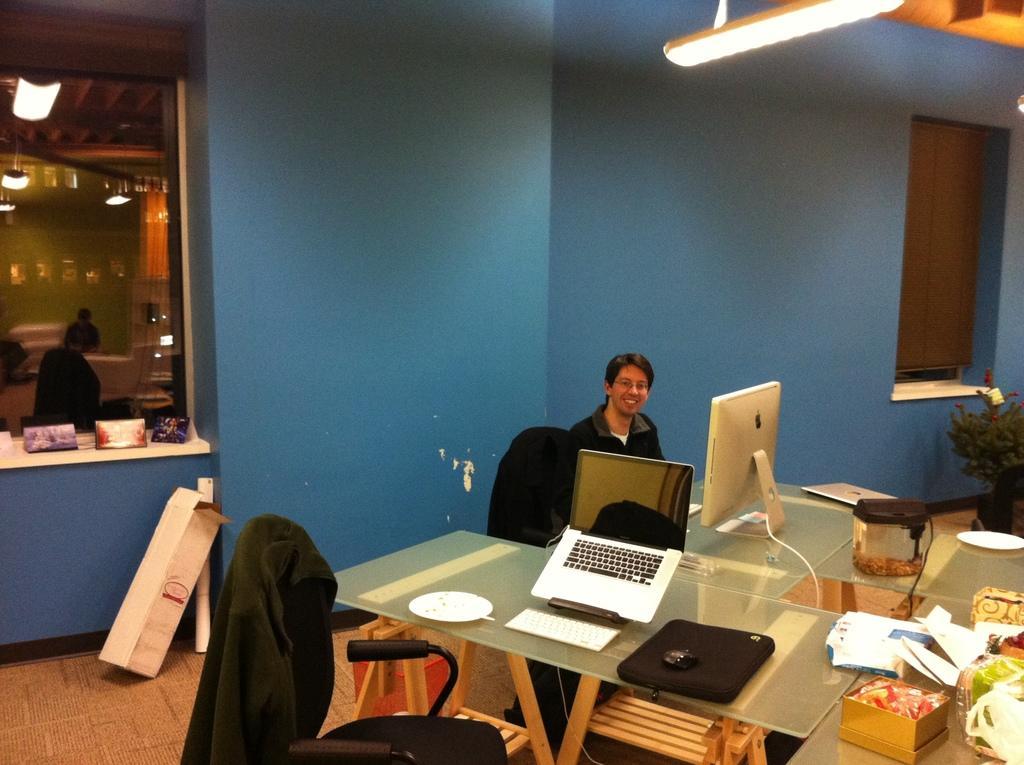Please provide a concise description of this image. In this picture there is a guy sitting on the table and apple monitor is in front of him. We also see an empty chair with laptop on the table , to the right side of the image there are many containers and there is also a tree in the background. We observe a glass window with a curtain and to the left side of the image there is a glass window and there is a light to the roof. 